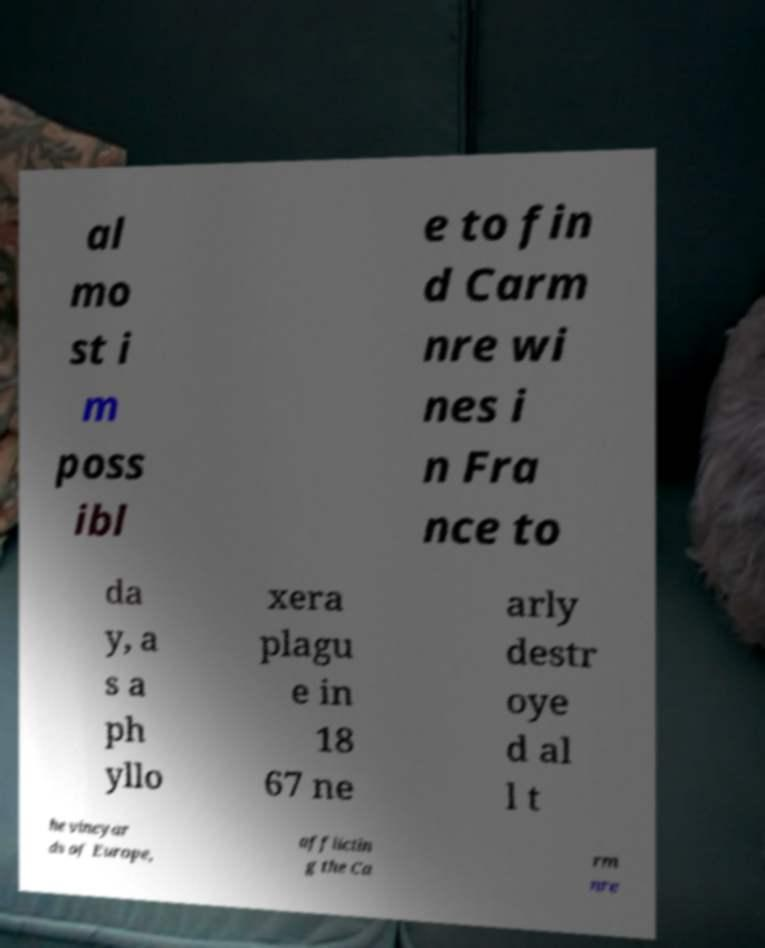What messages or text are displayed in this image? I need them in a readable, typed format. al mo st i m poss ibl e to fin d Carm nre wi nes i n Fra nce to da y, a s a ph yllo xera plagu e in 18 67 ne arly destr oye d al l t he vineyar ds of Europe, afflictin g the Ca rm nre 